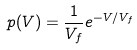<formula> <loc_0><loc_0><loc_500><loc_500>p ( V ) = \frac { 1 } { V _ { f } } e ^ { - V / V _ { f } }</formula> 